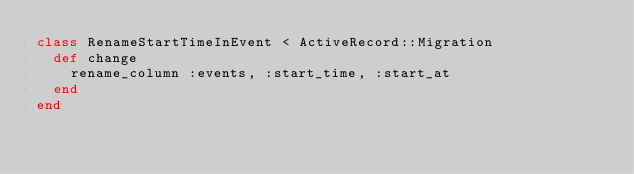<code> <loc_0><loc_0><loc_500><loc_500><_Ruby_>class RenameStartTimeInEvent < ActiveRecord::Migration
  def change
    rename_column :events, :start_time, :start_at
  end
end
</code> 